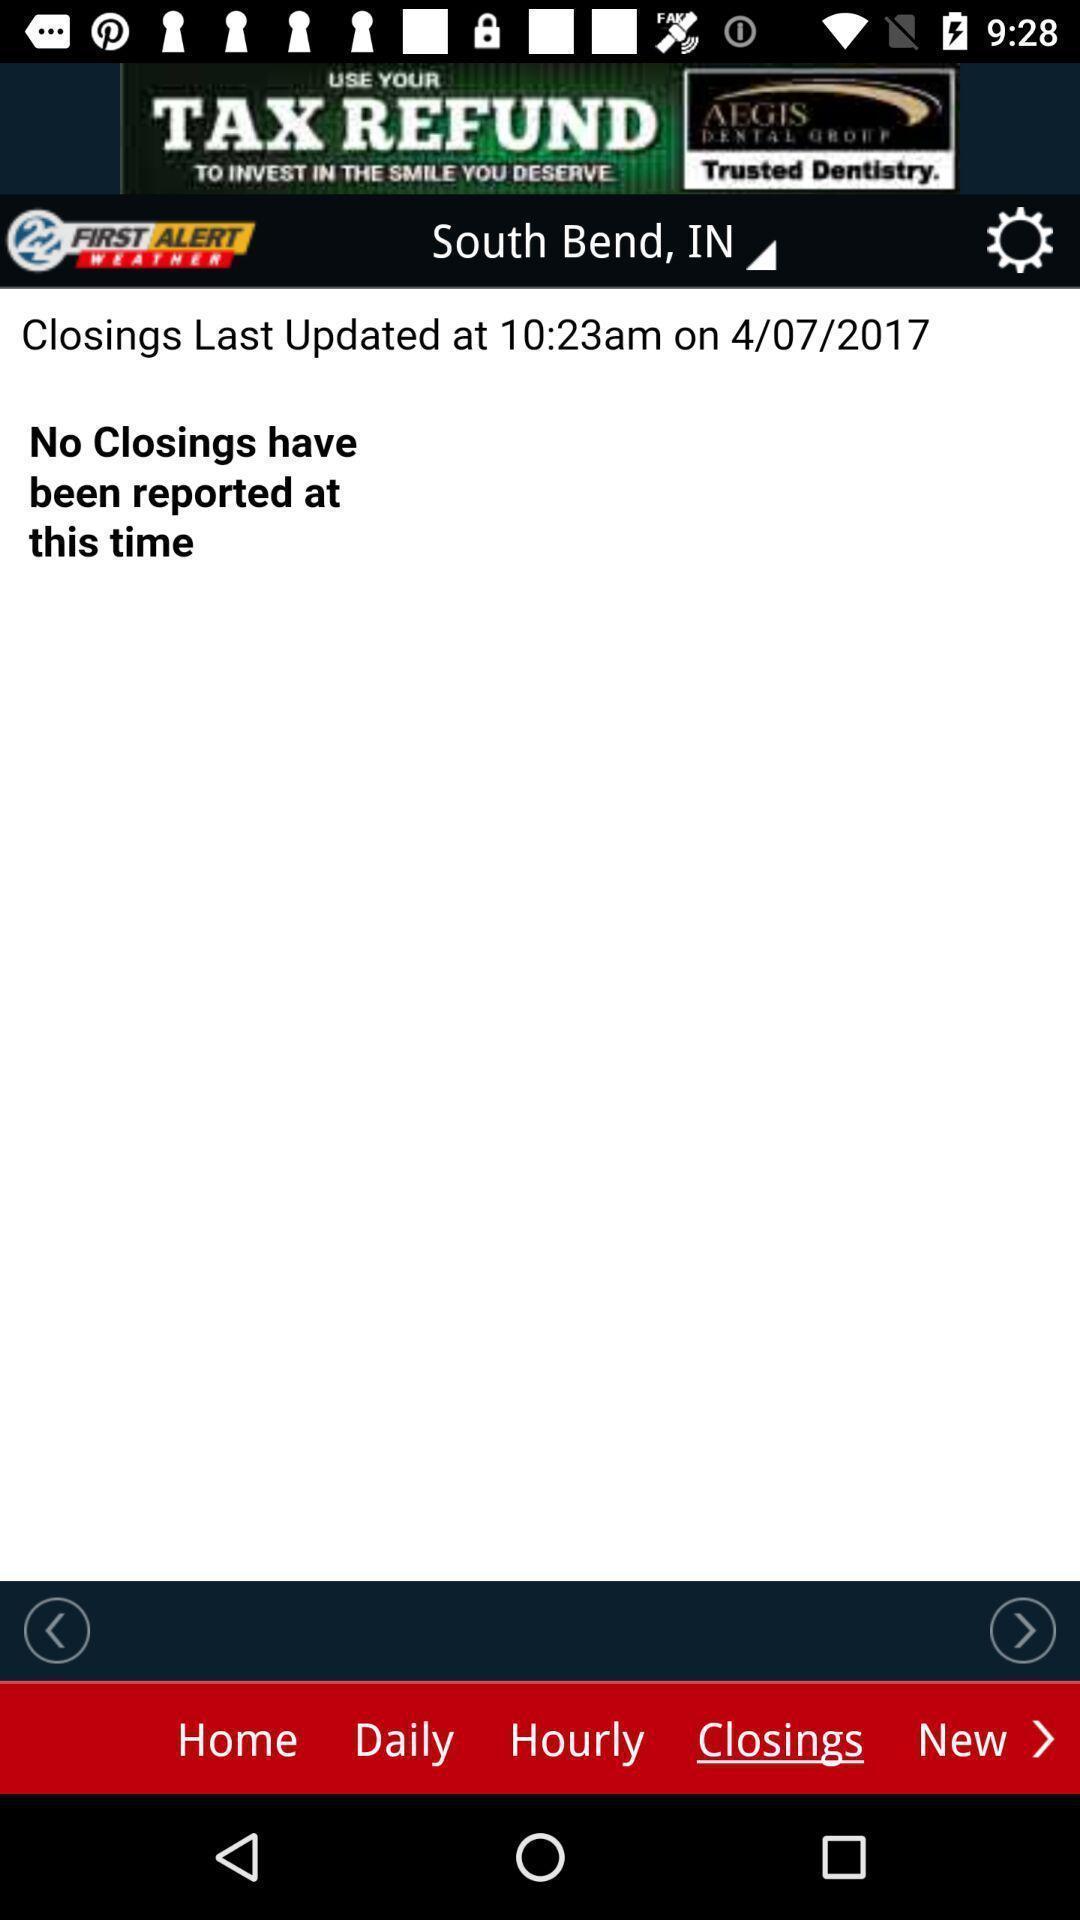Please provide a description for this image. Page displaying last updated time. 